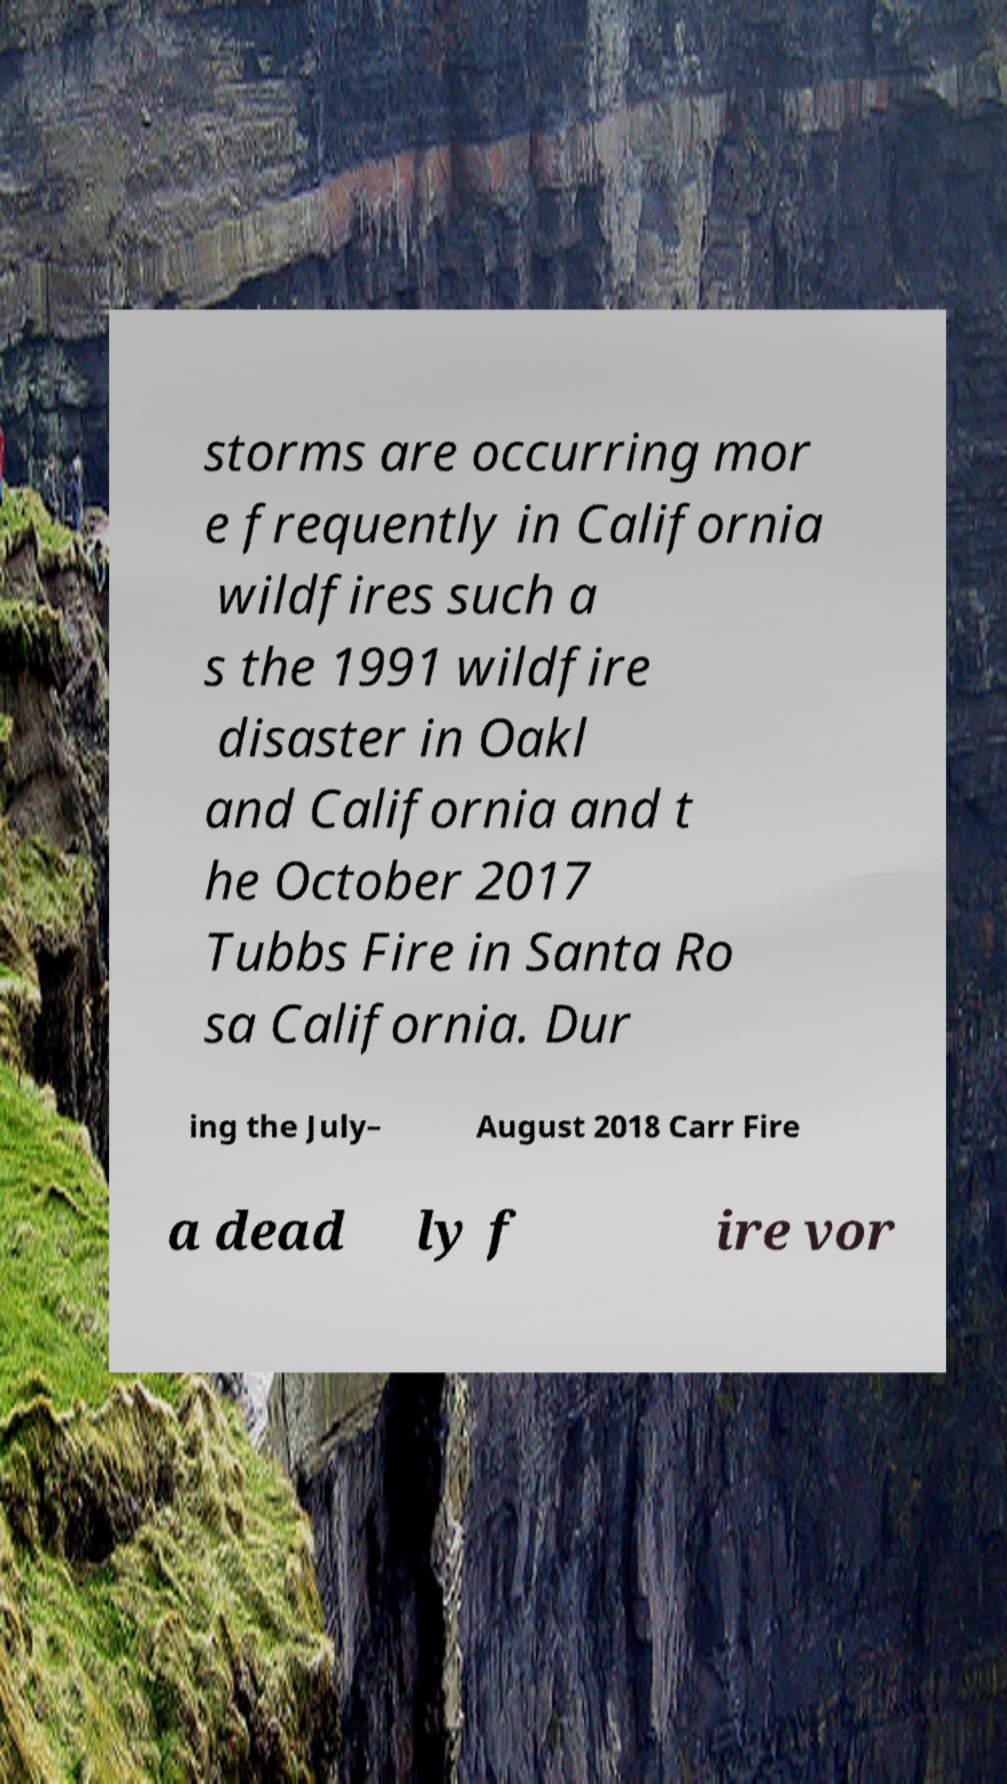For documentation purposes, I need the text within this image transcribed. Could you provide that? storms are occurring mor e frequently in California wildfires such a s the 1991 wildfire disaster in Oakl and California and t he October 2017 Tubbs Fire in Santa Ro sa California. Dur ing the July– August 2018 Carr Fire a dead ly f ire vor 